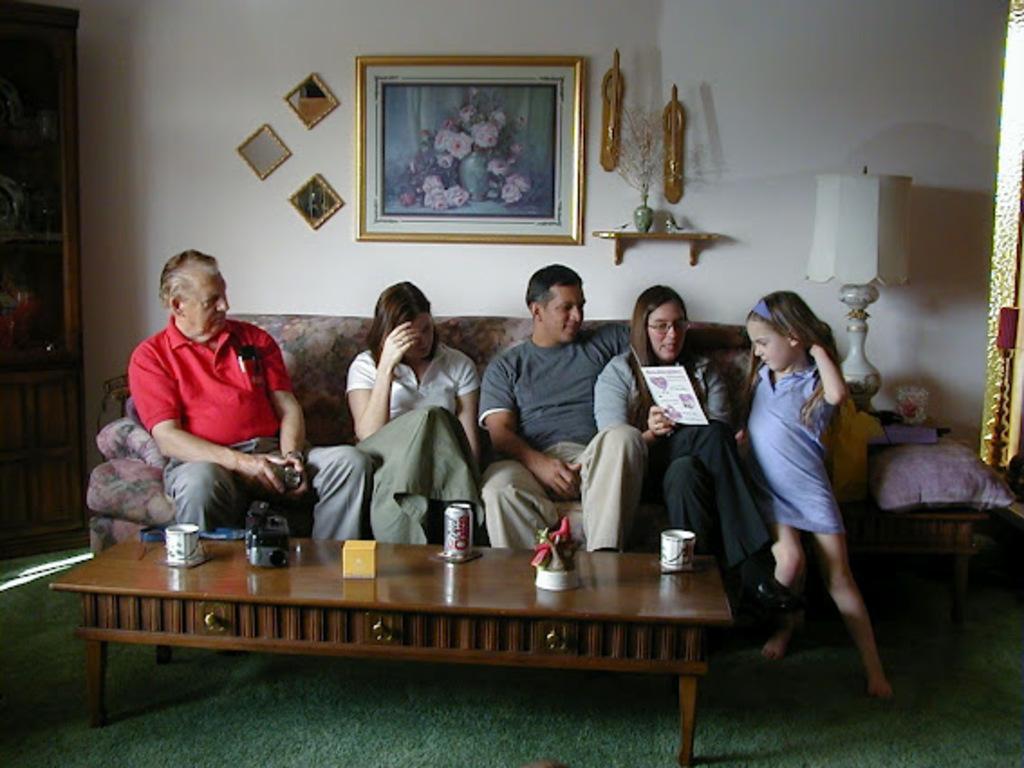Could you give a brief overview of what you see in this image? In this image, there are five persons sitting on the sofa, in front of the table on which cup, beverage can, box and camera is kept. The background wall is white in color on which photo frame is fixed. Beside that there is a table on which lamp is kept. In the left side, there is a cupboard. This image is taken inside a room during day time. 